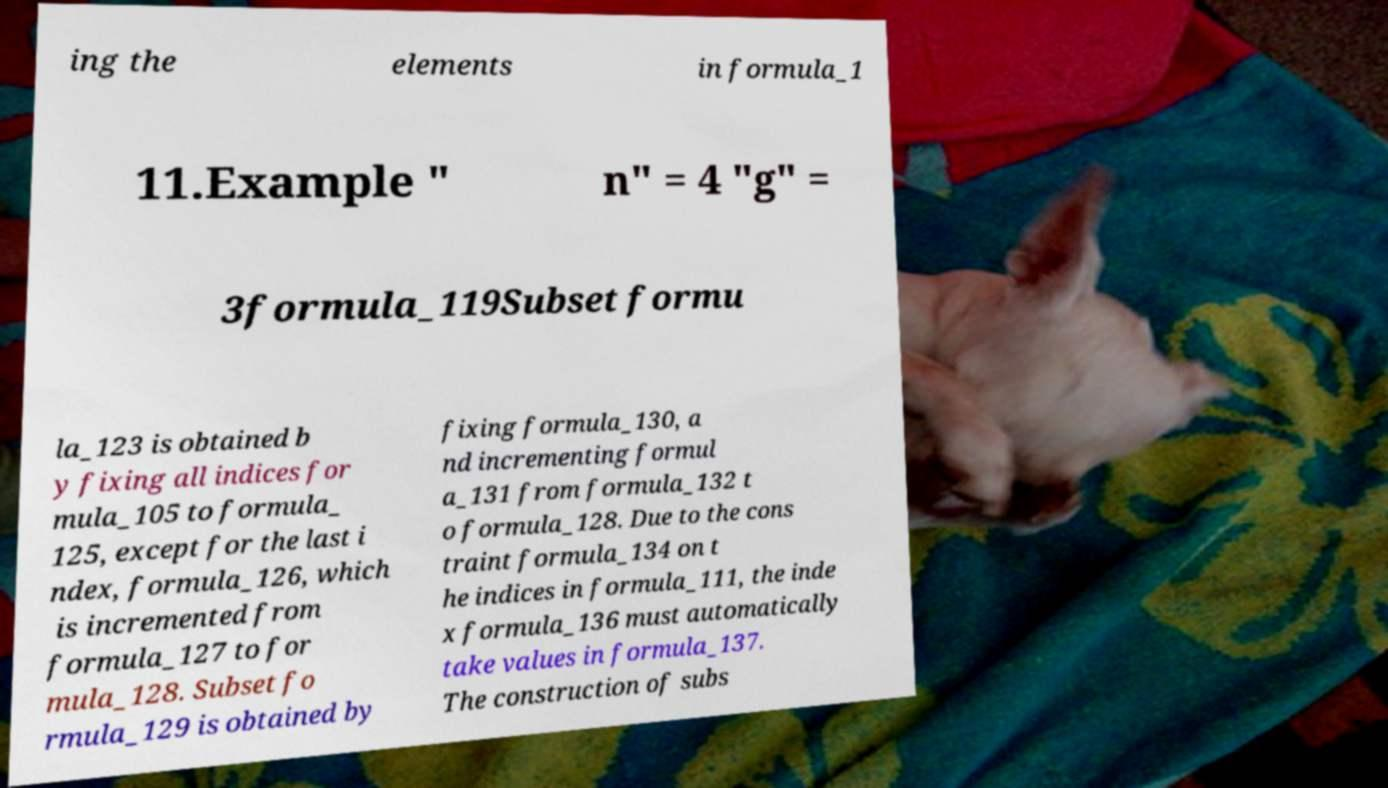For documentation purposes, I need the text within this image transcribed. Could you provide that? ing the elements in formula_1 11.Example " n" = 4 "g" = 3formula_119Subset formu la_123 is obtained b y fixing all indices for mula_105 to formula_ 125, except for the last i ndex, formula_126, which is incremented from formula_127 to for mula_128. Subset fo rmula_129 is obtained by fixing formula_130, a nd incrementing formul a_131 from formula_132 t o formula_128. Due to the cons traint formula_134 on t he indices in formula_111, the inde x formula_136 must automatically take values in formula_137. The construction of subs 